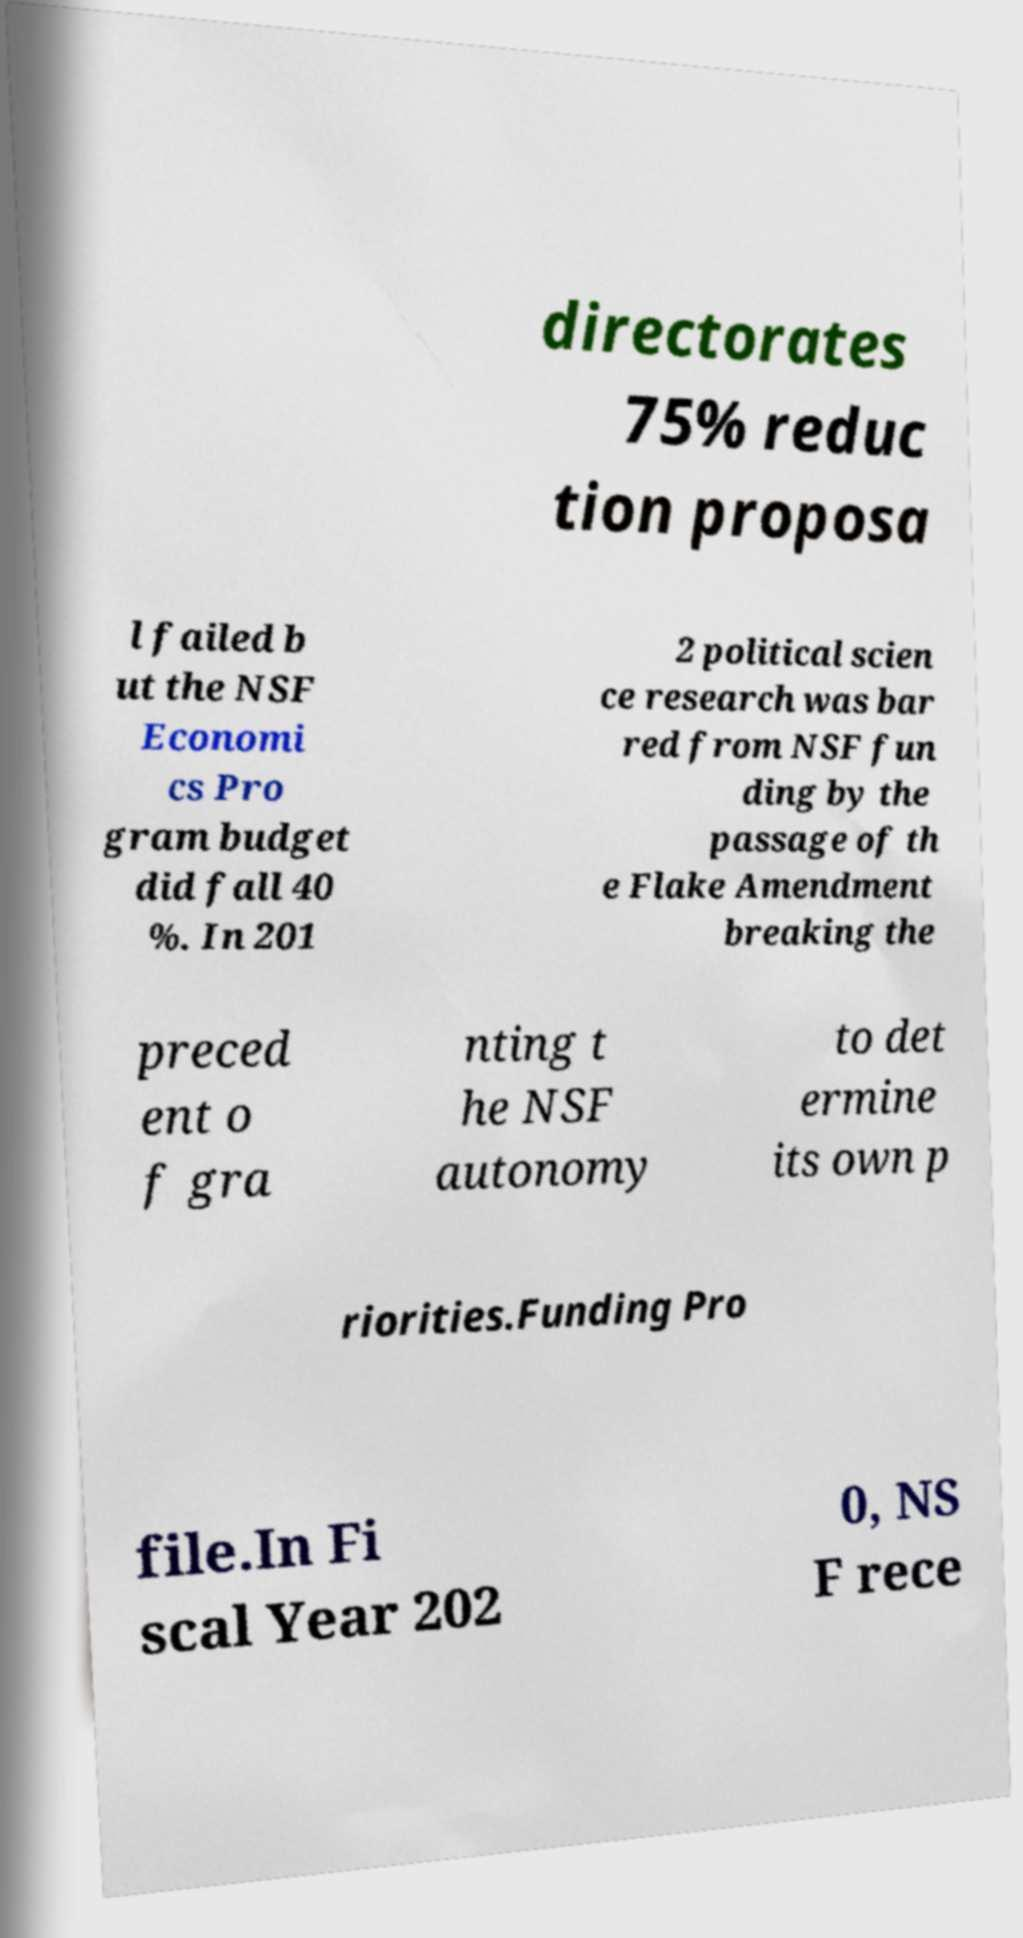Could you assist in decoding the text presented in this image and type it out clearly? directorates 75% reduc tion proposa l failed b ut the NSF Economi cs Pro gram budget did fall 40 %. In 201 2 political scien ce research was bar red from NSF fun ding by the passage of th e Flake Amendment breaking the preced ent o f gra nting t he NSF autonomy to det ermine its own p riorities.Funding Pro file.In Fi scal Year 202 0, NS F rece 